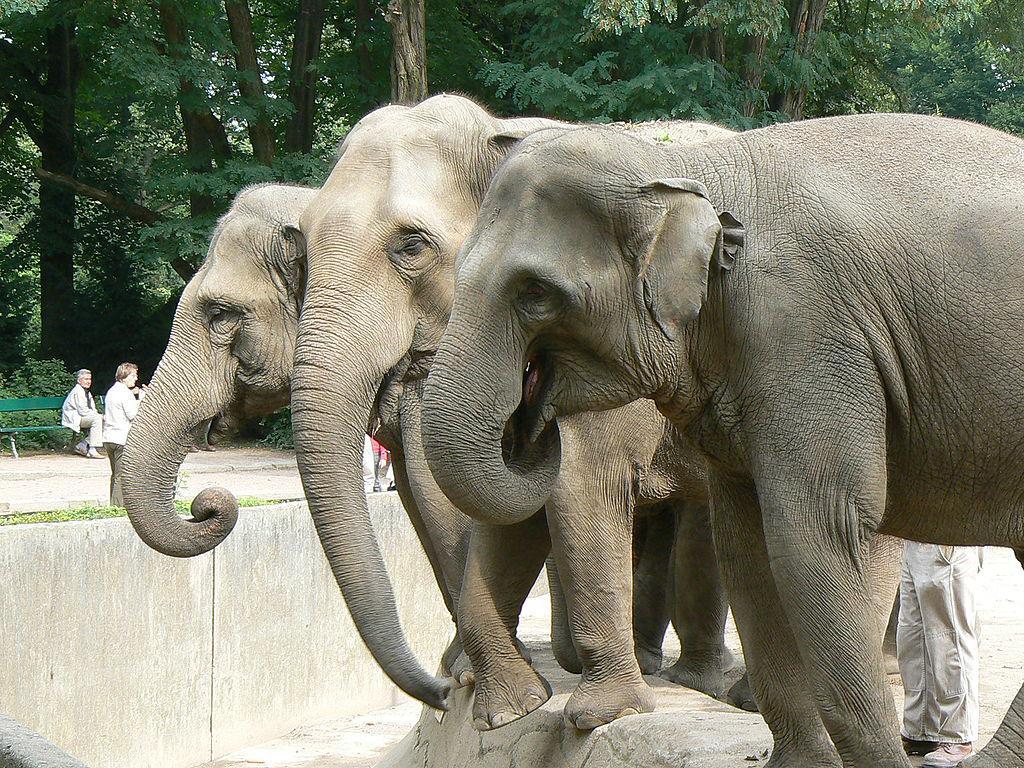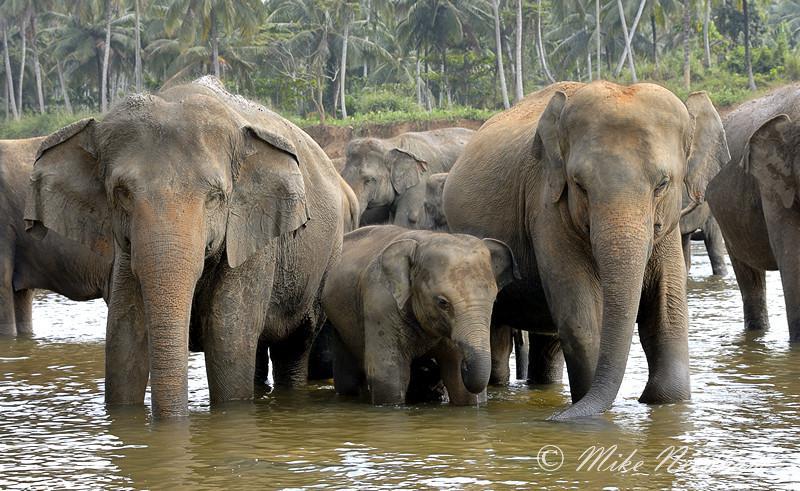The first image is the image on the left, the second image is the image on the right. Evaluate the accuracy of this statement regarding the images: "There is a baby elephant among adult elephants.". Is it true? Answer yes or no. Yes. 